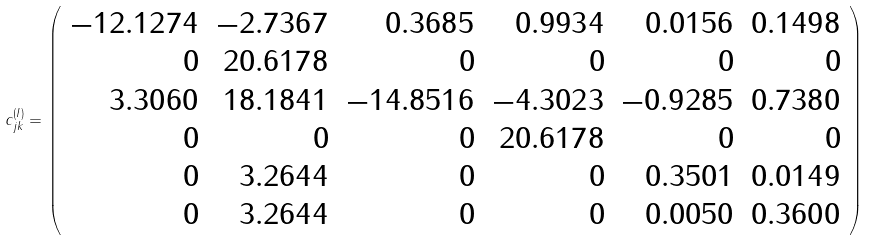<formula> <loc_0><loc_0><loc_500><loc_500>c _ { j k } ^ { ( I ) } = \left ( \begin{array} { r r r r r r } - 1 2 . 1 2 7 4 & - 2 . 7 3 6 7 & 0 . 3 6 8 5 & 0 . 9 9 3 4 & 0 . 0 1 5 6 & 0 . 1 4 9 8 \\ 0 & 2 0 . 6 1 7 8 & 0 & 0 & 0 & 0 \\ 3 . 3 0 6 0 & 1 8 . 1 8 4 1 & - 1 4 . 8 5 1 6 & - 4 . 3 0 2 3 & - 0 . 9 2 8 5 & 0 . 7 3 8 0 \\ 0 & 0 & 0 & 2 0 . 6 1 7 8 & 0 & 0 \\ 0 & 3 . 2 6 4 4 & 0 & 0 & 0 . 3 5 0 1 & 0 . 0 1 4 9 \\ 0 & 3 . 2 6 4 4 & 0 & 0 & 0 . 0 0 5 0 & 0 . 3 6 0 0 \end{array} \right )</formula> 